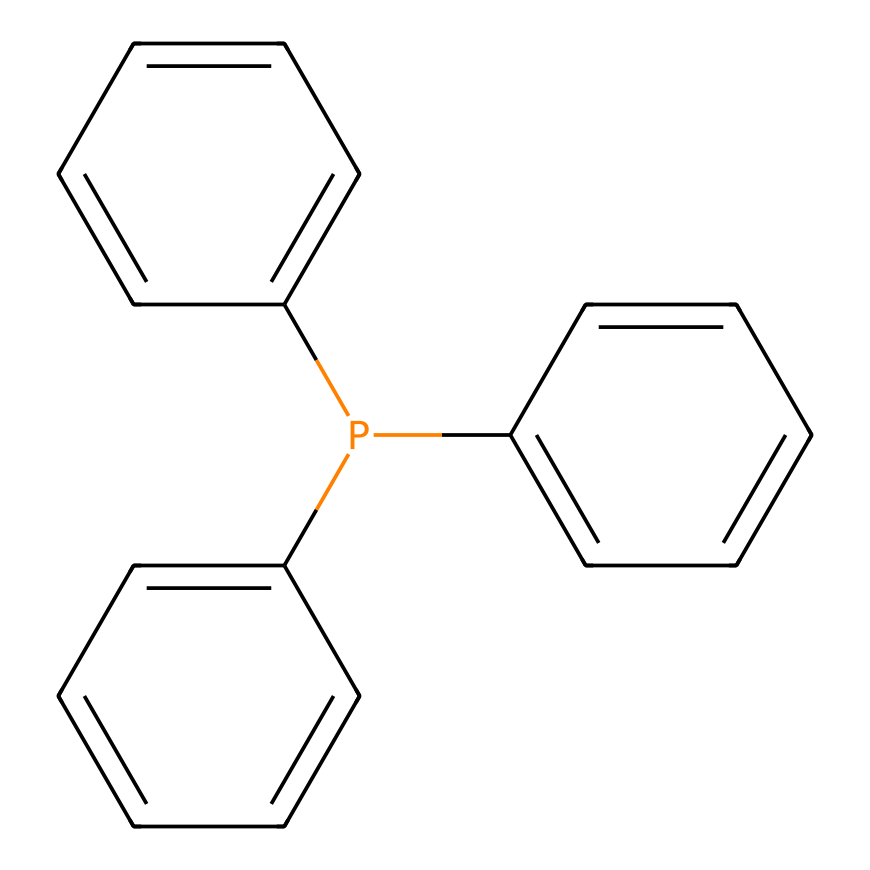What is the central atom in triphenylphosphine? The structure contains a phosphorus atom that is bonded to three distinct phenyl groups. The phosphorus atom serves as the central atom in the molecule.
Answer: phosphorus How many phenyl groups are attached to the phosphorus atom? The molecular structure includes three phenyl (C6H5) groups directly bonded to the phosphorus atom. Counting these groups gives three.
Answer: three What is the hybridization of the phosphorus atom in triphenylphosphine? The phosphorus atom exhibits sp3 hybridization due to the presence of three single bonds with the phenyl groups and one lone pair of electrons, which allows for tetrahedral geometry.
Answer: sp3 Is triphenylphosphine a Lewis base or a Lewis acid? Given the presence of a lone pair of electrons on the phosphorus atom, triphenylphosphine can donate this lone pair, classifying it as a Lewis base.
Answer: Lewis base What is the molecular formula of triphenylphosphine? By analyzing the structural representation, we identify the number of carbon (C), hydrogen (H), and phosphorus (P) atoms in the structure, leading to the molecular formula C18H15P.
Answer: C18H15P 